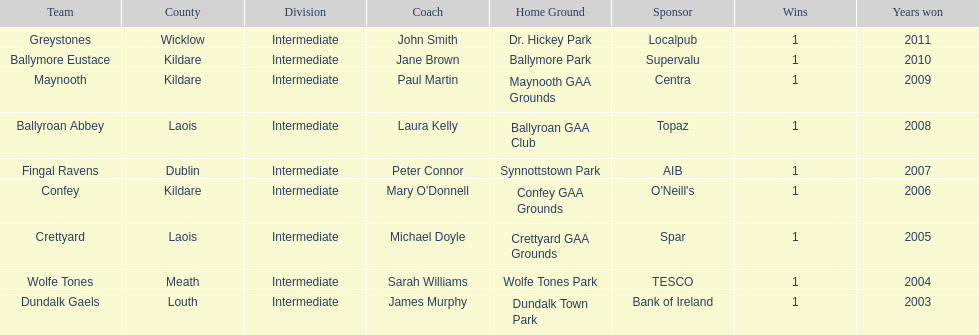How many wins did confey have? 1. 